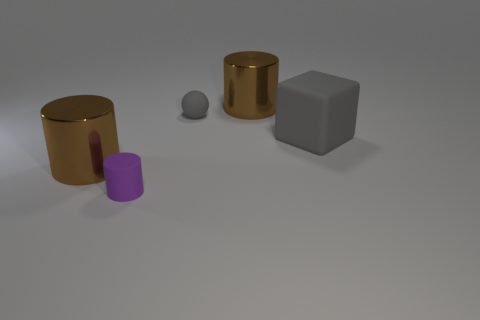Subtract all purple rubber cylinders. How many cylinders are left? 2 Subtract 1 cylinders. How many cylinders are left? 2 Add 5 big red things. How many big red things exist? 5 Add 3 metal objects. How many objects exist? 8 Subtract all brown cylinders. How many cylinders are left? 1 Subtract 1 gray blocks. How many objects are left? 4 Subtract all cylinders. How many objects are left? 2 Subtract all blue spheres. Subtract all blue blocks. How many spheres are left? 1 Subtract all red cylinders. How many green balls are left? 0 Subtract all tiny yellow objects. Subtract all purple rubber cylinders. How many objects are left? 4 